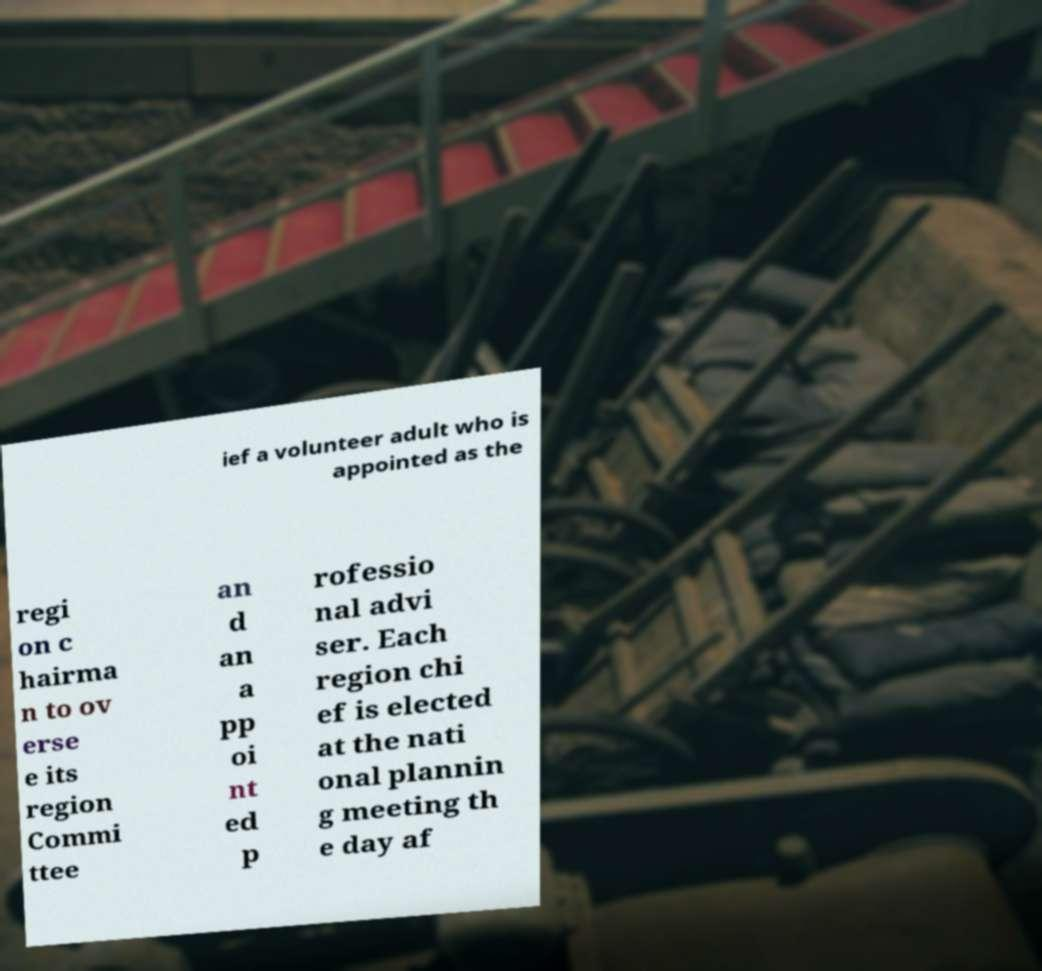Could you assist in decoding the text presented in this image and type it out clearly? ief a volunteer adult who is appointed as the regi on c hairma n to ov erse e its region Commi ttee an d an a pp oi nt ed p rofessio nal advi ser. Each region chi ef is elected at the nati onal plannin g meeting th e day af 